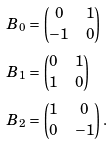<formula> <loc_0><loc_0><loc_500><loc_500>B _ { 0 } & = \begin{pmatrix} 0 & 1 \\ - 1 & 0 \end{pmatrix} \\ B _ { 1 } & = \begin{pmatrix} 0 & 1 \\ 1 & 0 \end{pmatrix} \\ B _ { 2 } & = \begin{pmatrix} 1 & 0 \\ 0 & - 1 \end{pmatrix} .</formula> 